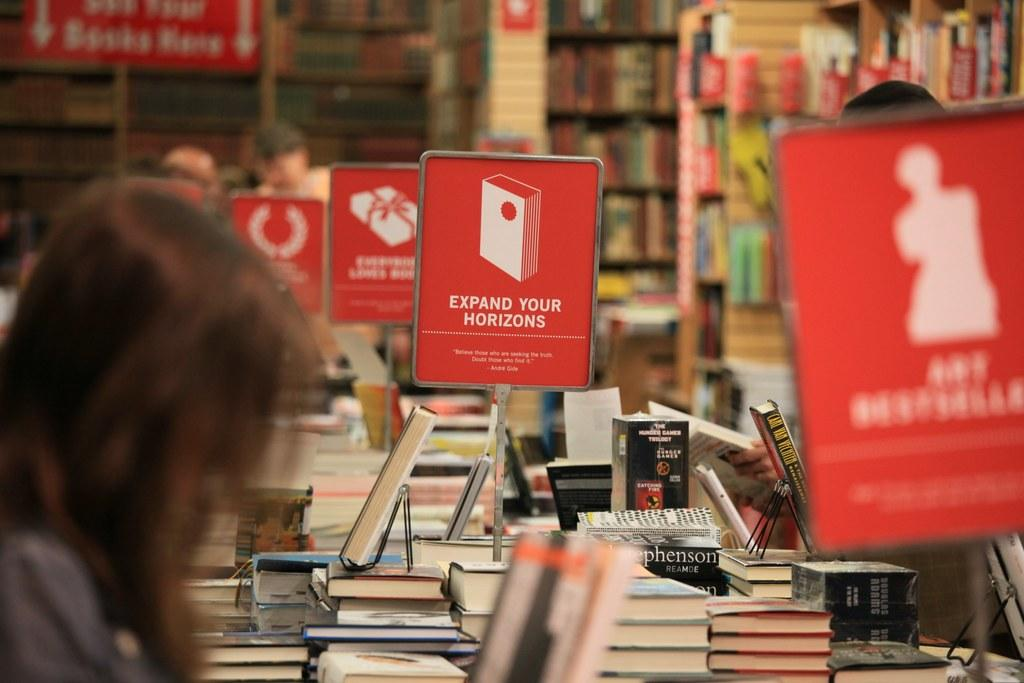<image>
Summarize the visual content of the image. A lady looking at a book exhibit with different signs, one says expand your horizons. 